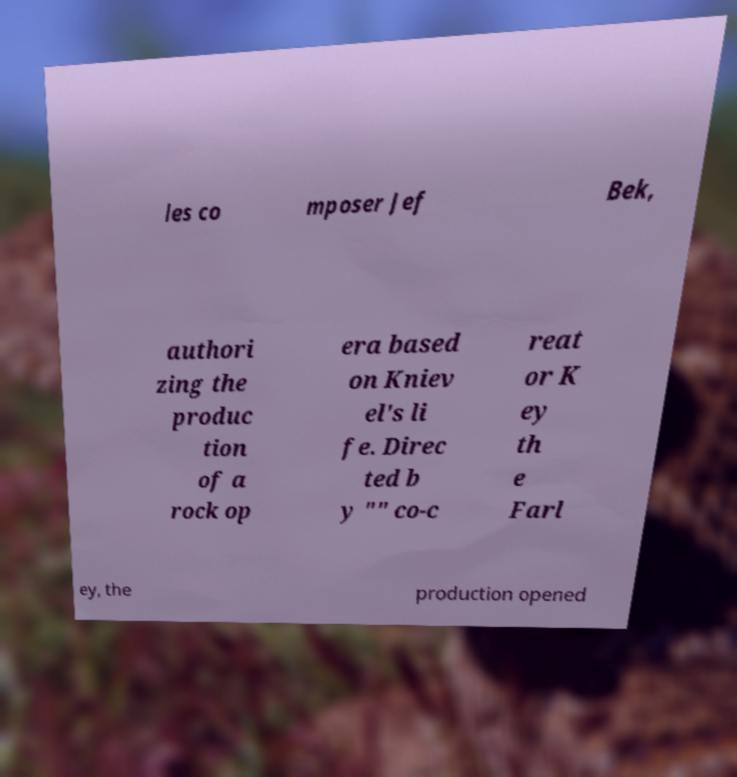Can you read and provide the text displayed in the image?This photo seems to have some interesting text. Can you extract and type it out for me? les co mposer Jef Bek, authori zing the produc tion of a rock op era based on Kniev el's li fe. Direc ted b y "" co-c reat or K ey th e Farl ey, the production opened 